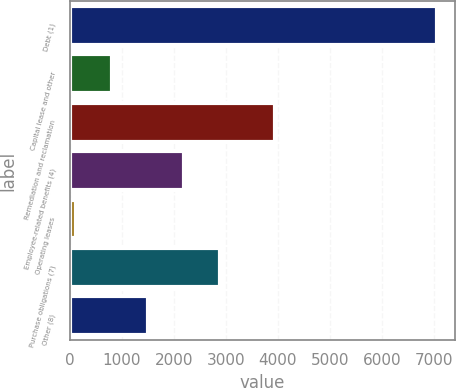Convert chart to OTSL. <chart><loc_0><loc_0><loc_500><loc_500><bar_chart><fcel>Debt (1)<fcel>Capital lease and other<fcel>Remediation and reclamation<fcel>Employee-related benefits (4)<fcel>Operating leases<fcel>Purchase obligations (7)<fcel>Other (8)<nl><fcel>7060<fcel>805<fcel>3944<fcel>2195<fcel>110<fcel>2890<fcel>1500<nl></chart> 